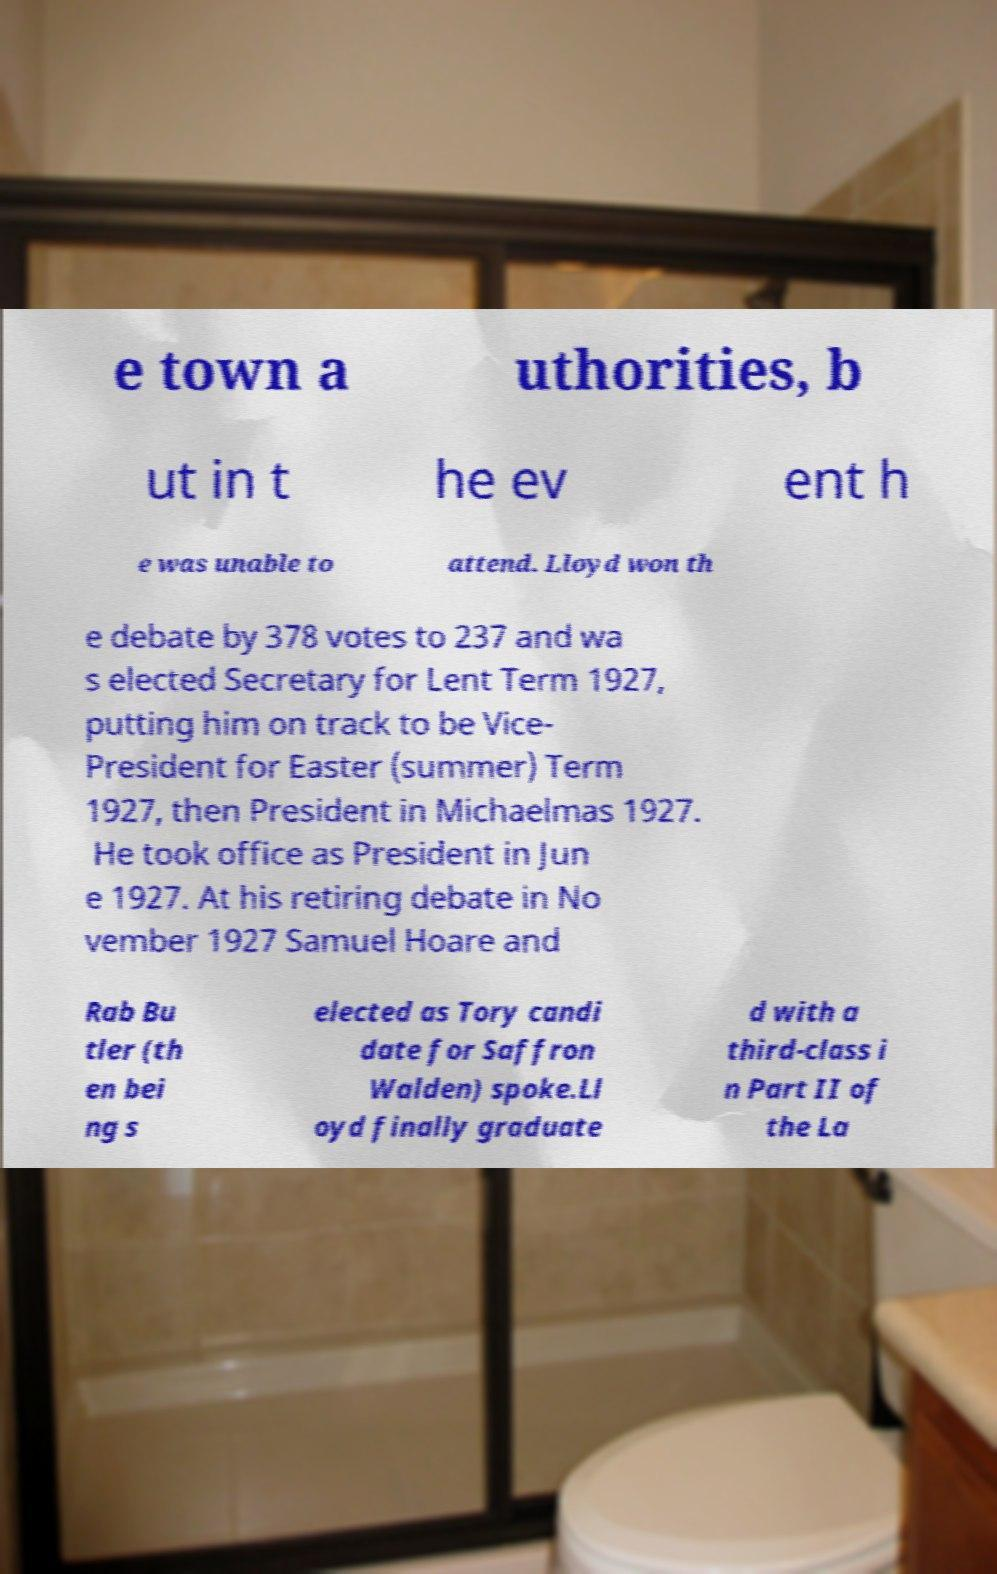Please read and relay the text visible in this image. What does it say? e town a uthorities, b ut in t he ev ent h e was unable to attend. Lloyd won th e debate by 378 votes to 237 and wa s elected Secretary for Lent Term 1927, putting him on track to be Vice- President for Easter (summer) Term 1927, then President in Michaelmas 1927. He took office as President in Jun e 1927. At his retiring debate in No vember 1927 Samuel Hoare and Rab Bu tler (th en bei ng s elected as Tory candi date for Saffron Walden) spoke.Ll oyd finally graduate d with a third-class i n Part II of the La 